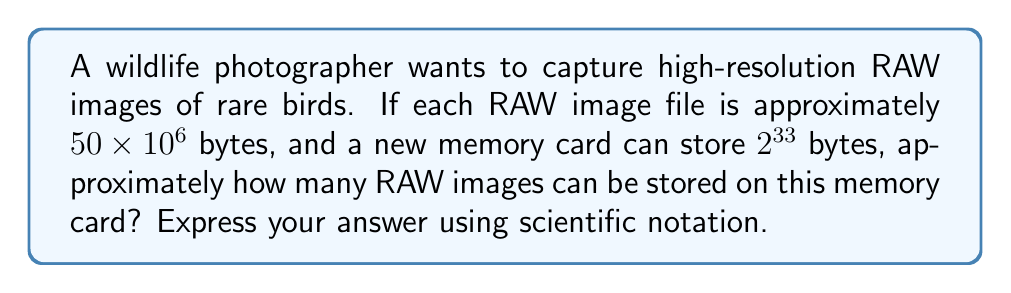Show me your answer to this math problem. Let's approach this step-by-step:

1) First, we need to convert the memory card storage capacity from $2^{33}$ bytes to a decimal number:

   $2^{33} = 8,589,934,592$ bytes

2) Now, we need to divide this capacity by the size of each RAW image file:

   $\frac{8,589,934,592}{50 \times 10^6}$

3) Let's simplify this fraction:

   $\frac{8,589,934,592}{50 \times 10^6} = \frac{8,589.934592}{50}$

4) Dividing:

   $\frac{8,589.934592}{50} \approx 171.79869184$

5) Rounding to two decimal places:

   $171.80$

6) To express this in scientific notation, we move the decimal point two places to the left and multiply by $10^2$:

   $1.72 \times 10^2$

Therefore, approximately $1.72 \times 10^2$ RAW images can be stored on this memory card.
Answer: $1.72 \times 10^2$ images 